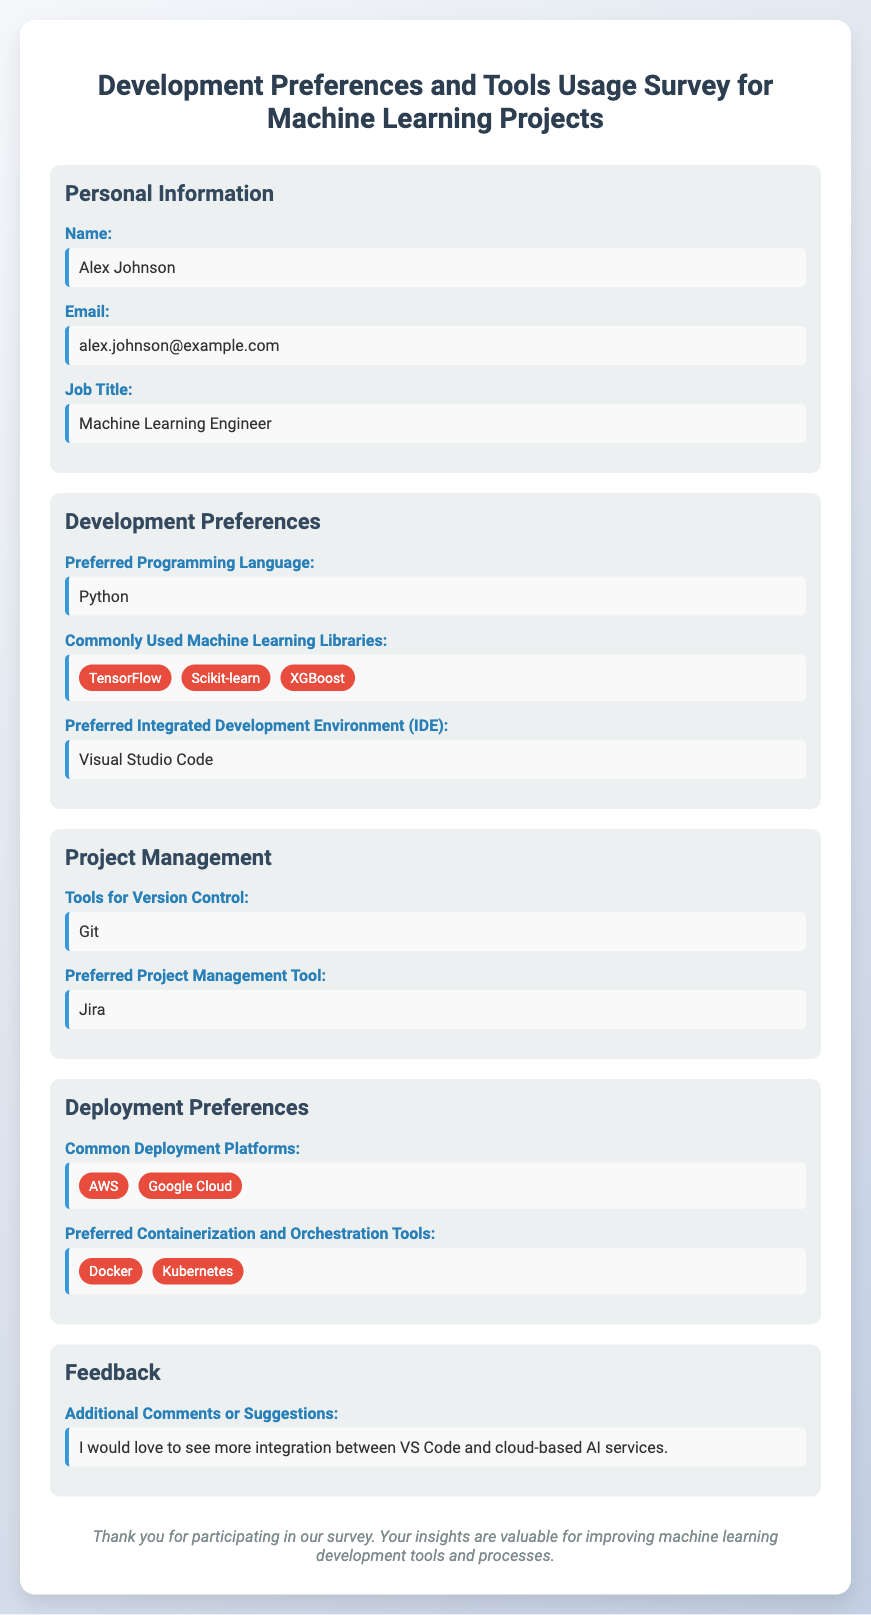What is the name of the participant? The name of the participant is explicitly mentioned in the personal information section.
Answer: Alex Johnson What is the preferred programming language? The preferred programming language is indicated under development preferences.
Answer: Python Which machine learning library is commonly used that is mentioned in the survey? The survey lists commonly used machine learning libraries, including TensorFlow, Scikit-learn, and XGBoost.
Answer: TensorFlow What tool is listed for version control? The tool for version control is specified in the project management section.
Answer: Git What is the preferred IDE? The preferred integrated development environment is stated in the development preferences.
Answer: Visual Studio Code What are the common deployment platforms mentioned? The common deployment platforms are listed under deployment preferences, including AWS and Google Cloud.
Answer: AWS Which project management tool is preferred? The preferred project management tool can be found in the project management section of the survey.
Answer: Jira What containerization tool is mentioned? The survey lists preferred containerization and orchestration tools, which include Docker and Kubernetes.
Answer: Docker What feedback did the participant provide? The feedback is found in the feedback section of the document.
Answer: I would love to see more integration between VS Code and cloud-based AI services 